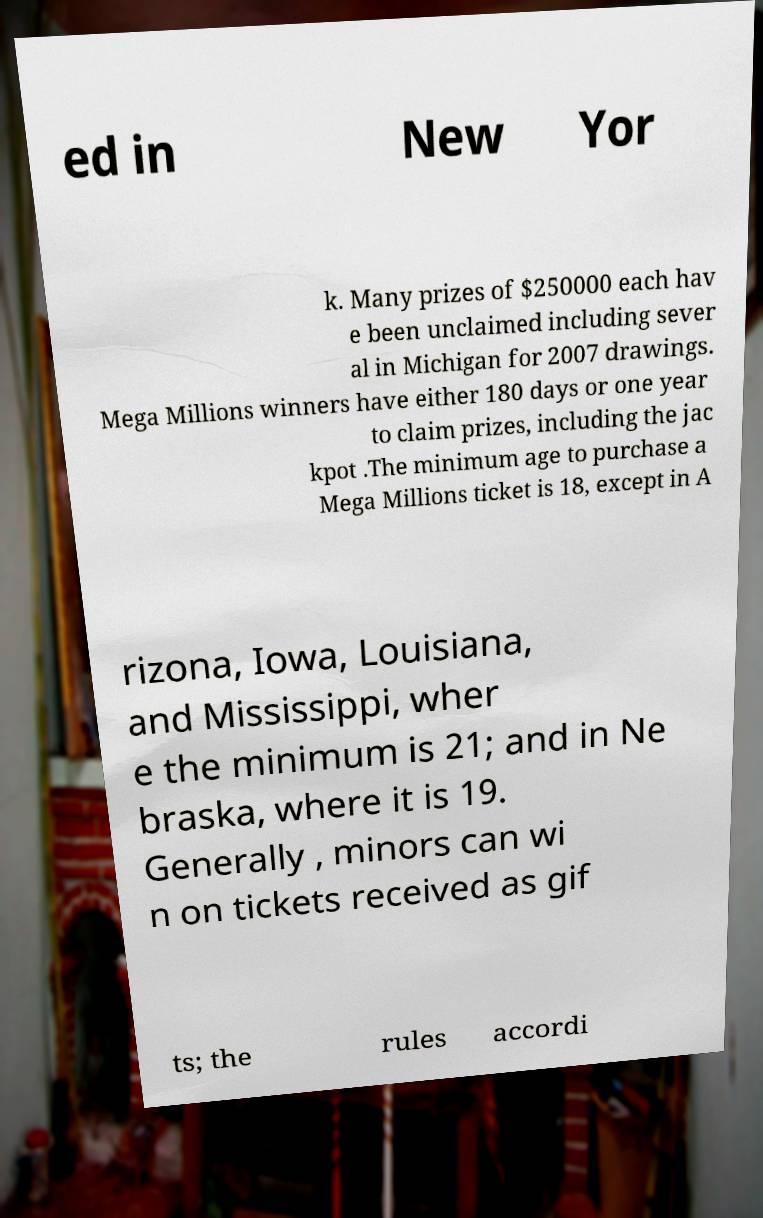Please read and relay the text visible in this image. What does it say? ed in New Yor k. Many prizes of $250000 each hav e been unclaimed including sever al in Michigan for 2007 drawings. Mega Millions winners have either 180 days or one year to claim prizes, including the jac kpot .The minimum age to purchase a Mega Millions ticket is 18, except in A rizona, Iowa, Louisiana, and Mississippi, wher e the minimum is 21; and in Ne braska, where it is 19. Generally , minors can wi n on tickets received as gif ts; the rules accordi 